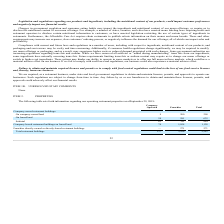According to Jack In The Box's financial document, What are the consequences if legislations and regulations target our products, ingredients and the nutritional content of our products? Based on the financial document, the answer is Impact customer preferences and negatively impact our financial results. Also, What are the consequences if the company fails to obtain and maintain required licenses and permits or fails to comply with food regulations? Loss of our food service licenses and, thereby, harm our business.. The document states: "ly with food control regulations could lead to the loss of our food service licenses and, thereby, harm our business...." Also, What is the grand total of both company-operated and franchise restaurants together? According to the financial document, 2,243. The relevant text states: "Total restaurant buildings 137 2,106 2,243..." Also, can you calculate: What is the difference between the number of company-operated and franchise restaurants? Based on the calculation: 2,106 - 137 , the result is 1969. This is based on the information: "Total restaurant buildings 137 2,106 2,243 Total restaurant buildings 137 2,106 2,243..." The key data points involved are: 137, 2,106. Also, can you calculate: What is the percentage constitution of company-operated restaurants among the total restaurants? Based on the calculation: 137/2,243 , the result is 6.11 (percentage). This is based on the information: "Total restaurant buildings 137 2,106 2,243 Total restaurant buildings 137 2,106 2,243..." The key data points involved are: 137, 2,243. Also, can you calculate: What is the percentage constitution of franchise restaurant on leased land in the total number of franchise buildings?  Based on the calculation: 581/2,106 , the result is 27.59 (percentage). This is based on the information: "On leased land 54 581 635 Total restaurant buildings 137 2,106 2,243..." The key data points involved are: 2,106, 581. 